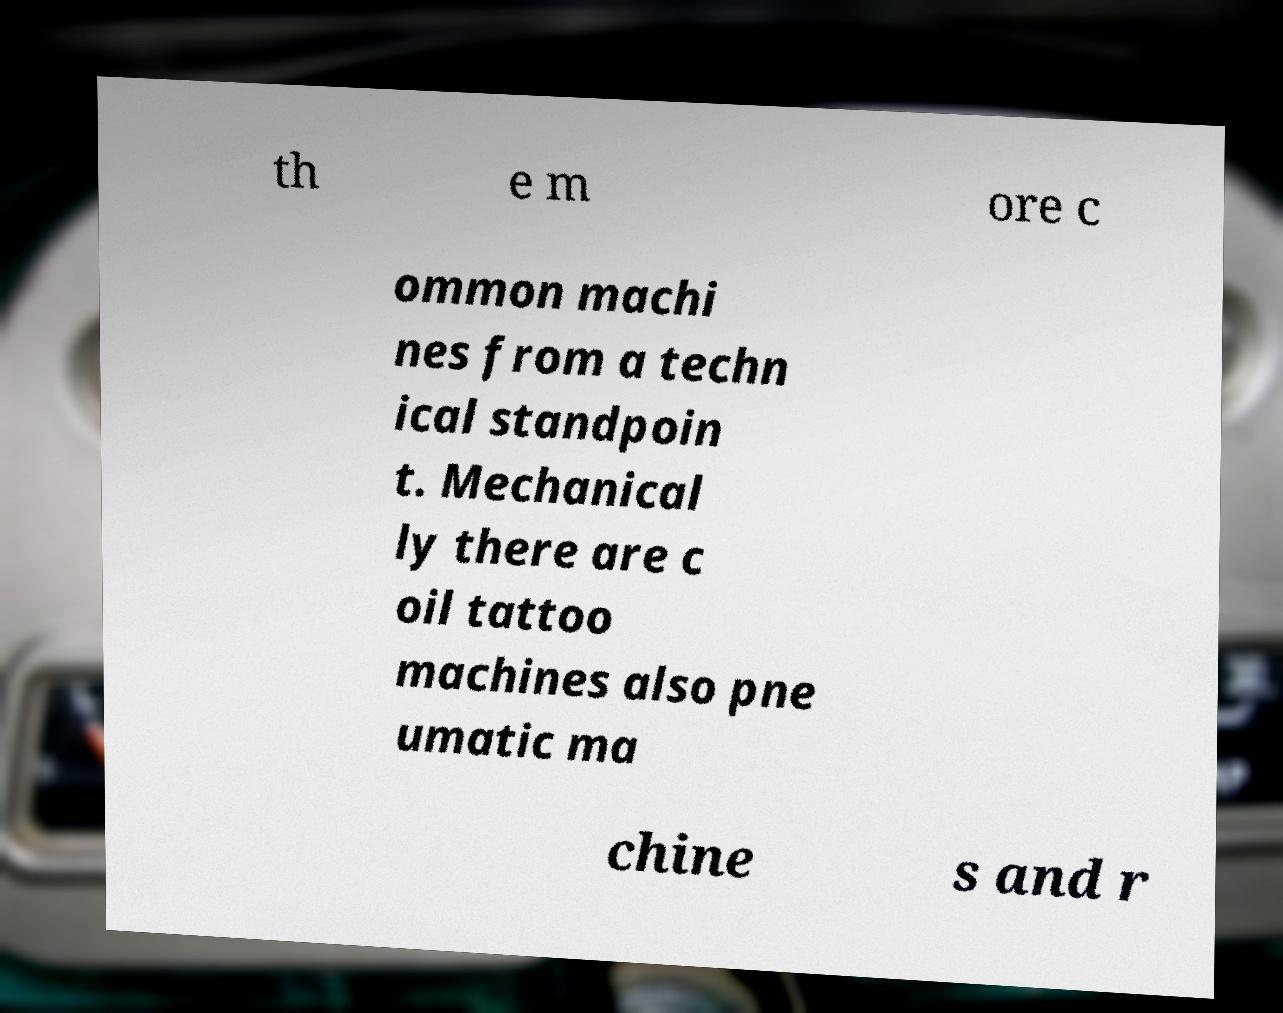Could you extract and type out the text from this image? th e m ore c ommon machi nes from a techn ical standpoin t. Mechanical ly there are c oil tattoo machines also pne umatic ma chine s and r 